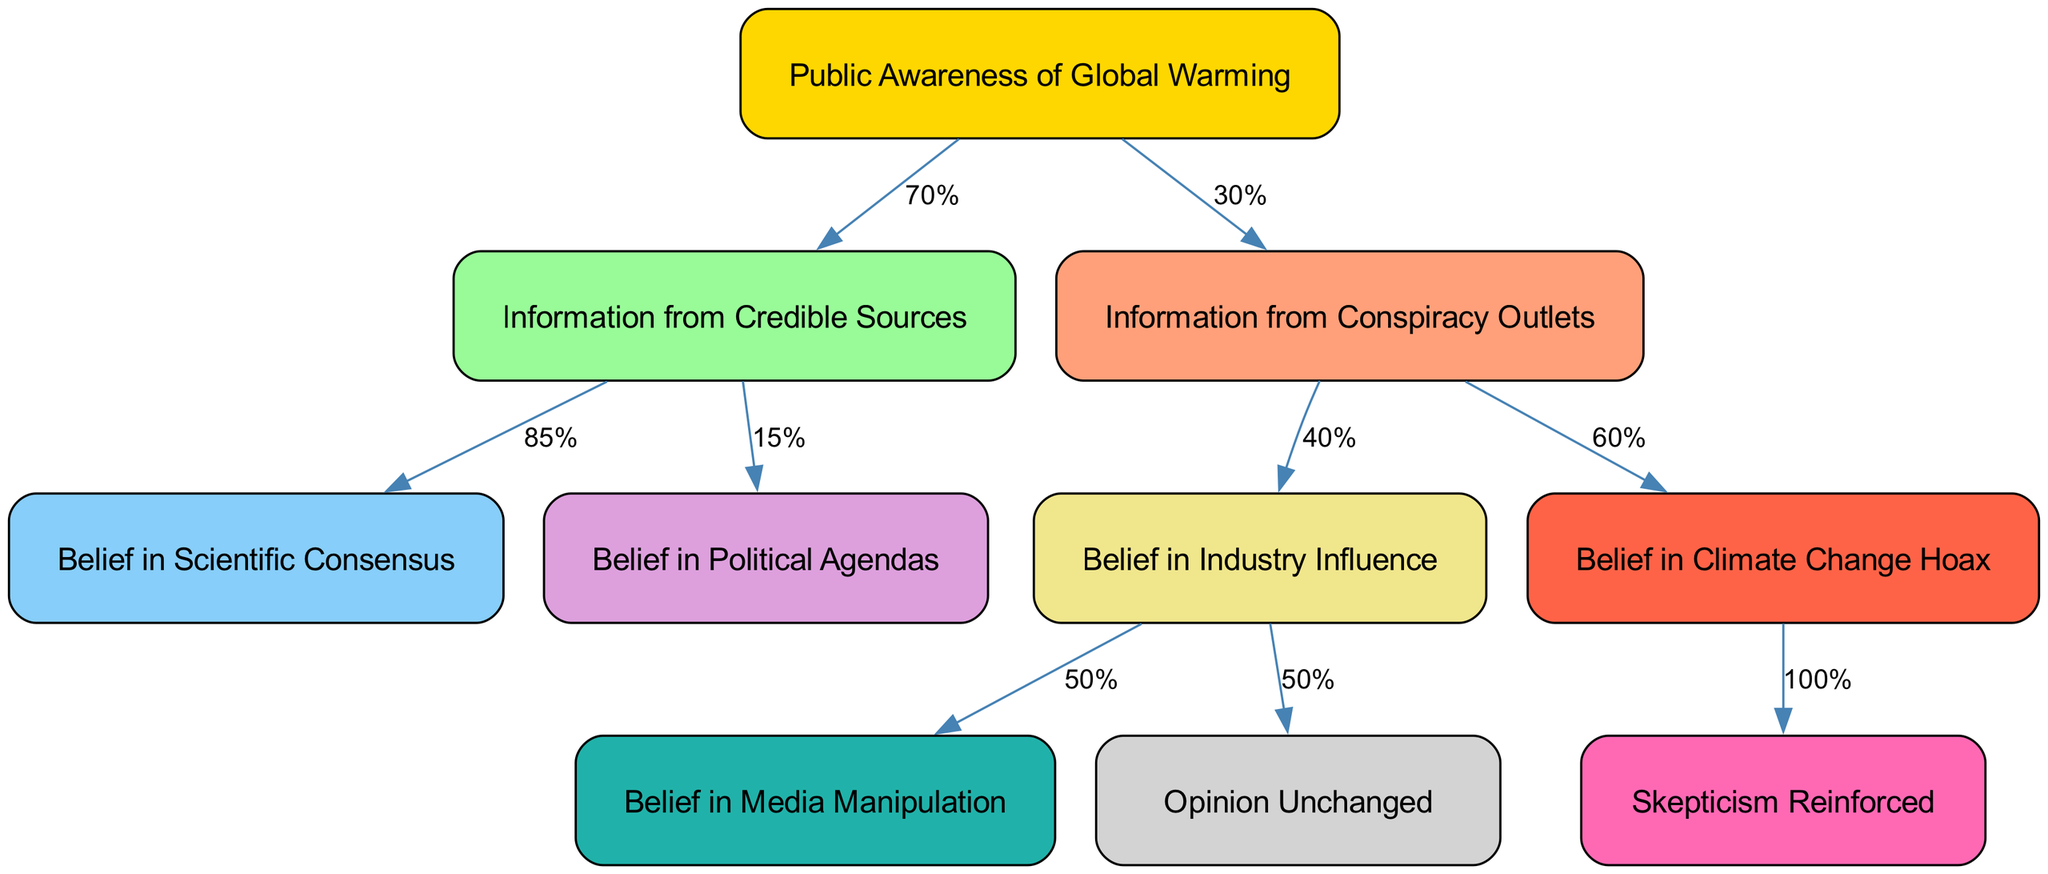What is the total number of nodes in the diagram? By counting each distinct node listed in the nodes section, we see there are 10 individual nodes representing different aspects of public opinion on global warming.
Answer: 10 What percentage of the public receives information from conspiracy outlets? The edges indicate that 30% of the public's awareness leads to the node for information from conspiracy outlets.
Answer: 30% What belief is connected to the node labeled 'credible_sources'? The two beliefs that come from the 'credible_sources' node are 'scientific_consensus' (85%) and 'political_agendas' (15%). The more significant connection leads to 'scientific_consensus'.
Answer: Scientific Consensus What is the probability of believing in a climate change hoax after consuming conspiracy information? From the edge connected to 'climate_hoax', once someone believes in a climate change hoax, it’s indicated to always lead to 'skepticism_reinforced' at a probability of 100%.
Answer: 100% If someone believes in industry influence, what are the two possible outcomes in terms of opinion? The node for 'industry_influence' directly connects to 'media_manipulation' (50%) and 'opinion_unchanged' (50%), implying equal chances for both outcomes.
Answer: Media Manipulation, Opinion Unchanged What belief is always reinforced after accepting the climate change hoax? The diagram indicates that belief in a climate change hoax leads directly to 'skepticism_reinforced', which is marked as a 100% certainty in the flow from the 'climate_hoax' node.
Answer: Skepticism Reinforced Which node represents the initial step in public awareness of global warming? The 'start' node is the initiating point in the diagram, serving as the entry into the flow of beliefs about global warming.
Answer: Public Awareness of Global Warming What is the edge probability that leads to believing political agendas from credible sources? The edge leading from 'credible_sources' to 'political_agendas' shows a probability of 15%, which reflects a lesser belief compared to 'scientific_consensus'.
Answer: 15% 